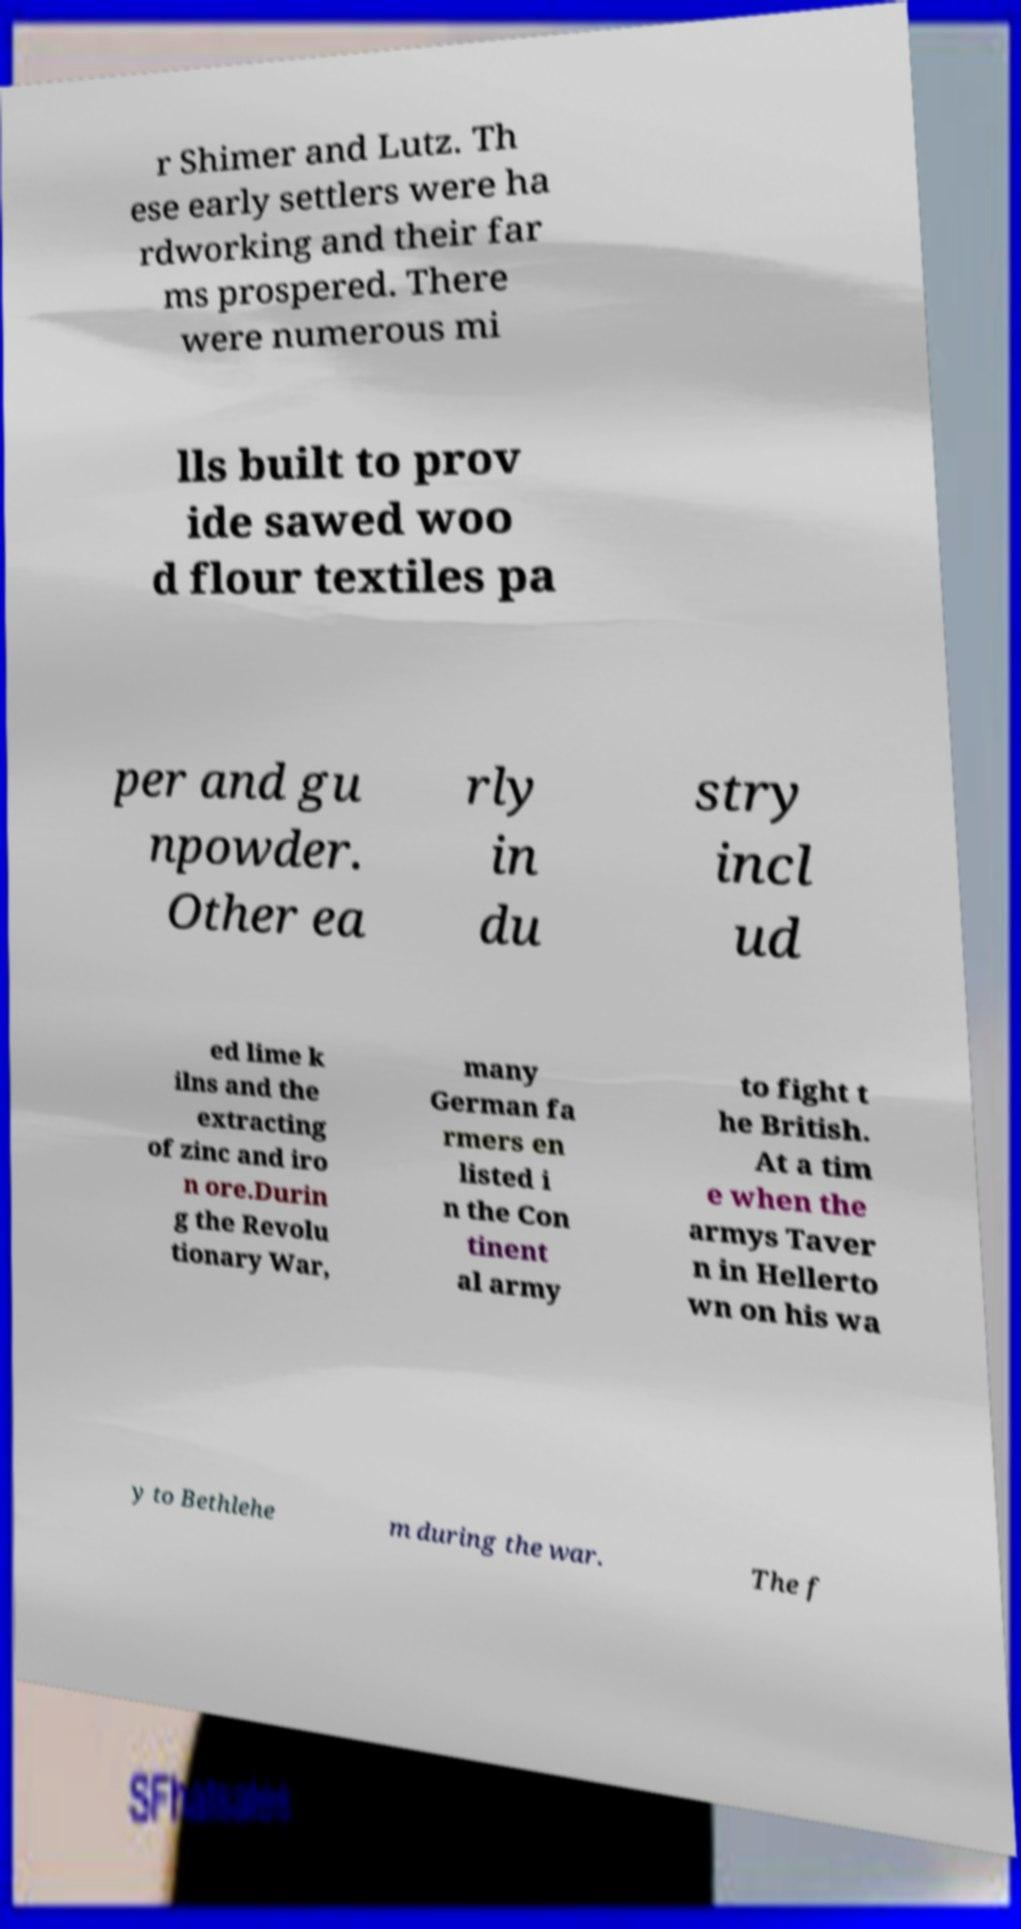For documentation purposes, I need the text within this image transcribed. Could you provide that? r Shimer and Lutz. Th ese early settlers were ha rdworking and their far ms prospered. There were numerous mi lls built to prov ide sawed woo d flour textiles pa per and gu npowder. Other ea rly in du stry incl ud ed lime k ilns and the extracting of zinc and iro n ore.Durin g the Revolu tionary War, many German fa rmers en listed i n the Con tinent al army to fight t he British. At a tim e when the armys Taver n in Hellerto wn on his wa y to Bethlehe m during the war. The f 